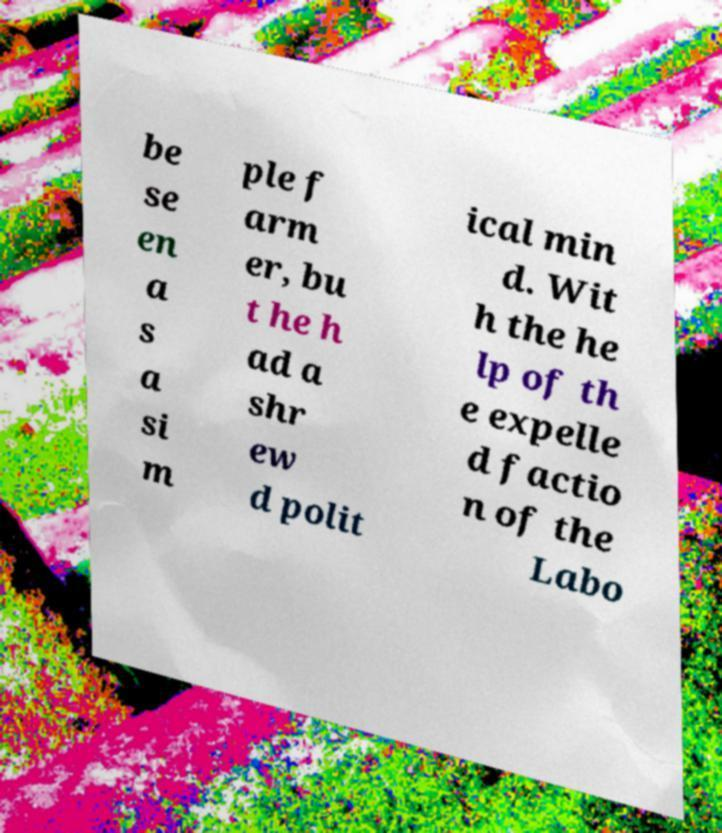I need the written content from this picture converted into text. Can you do that? be se en a s a si m ple f arm er, bu t he h ad a shr ew d polit ical min d. Wit h the he lp of th e expelle d factio n of the Labo 